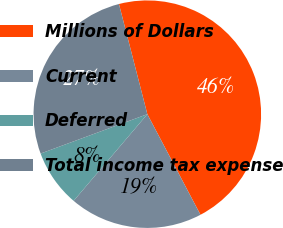Convert chart to OTSL. <chart><loc_0><loc_0><loc_500><loc_500><pie_chart><fcel>Millions of Dollars<fcel>Current<fcel>Deferred<fcel>Total income tax expense<nl><fcel>46.28%<fcel>18.95%<fcel>8.16%<fcel>26.61%<nl></chart> 